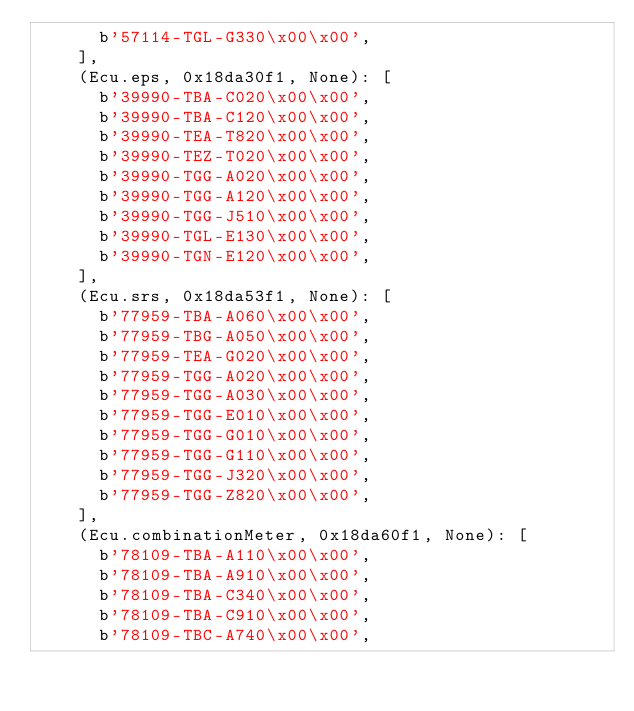<code> <loc_0><loc_0><loc_500><loc_500><_Python_>      b'57114-TGL-G330\x00\x00',
    ],
    (Ecu.eps, 0x18da30f1, None): [
      b'39990-TBA-C020\x00\x00',
      b'39990-TBA-C120\x00\x00',
      b'39990-TEA-T820\x00\x00',
      b'39990-TEZ-T020\x00\x00',
      b'39990-TGG-A020\x00\x00',
      b'39990-TGG-A120\x00\x00',
      b'39990-TGG-J510\x00\x00',
      b'39990-TGL-E130\x00\x00',
      b'39990-TGN-E120\x00\x00',
    ],
    (Ecu.srs, 0x18da53f1, None): [
      b'77959-TBA-A060\x00\x00',
      b'77959-TBG-A050\x00\x00',
      b'77959-TEA-G020\x00\x00',
      b'77959-TGG-A020\x00\x00',
      b'77959-TGG-A030\x00\x00',
      b'77959-TGG-E010\x00\x00',
      b'77959-TGG-G010\x00\x00',
      b'77959-TGG-G110\x00\x00',
      b'77959-TGG-J320\x00\x00',
      b'77959-TGG-Z820\x00\x00',
    ],
    (Ecu.combinationMeter, 0x18da60f1, None): [
      b'78109-TBA-A110\x00\x00',
      b'78109-TBA-A910\x00\x00',
      b'78109-TBA-C340\x00\x00',
      b'78109-TBA-C910\x00\x00',
      b'78109-TBC-A740\x00\x00',</code> 